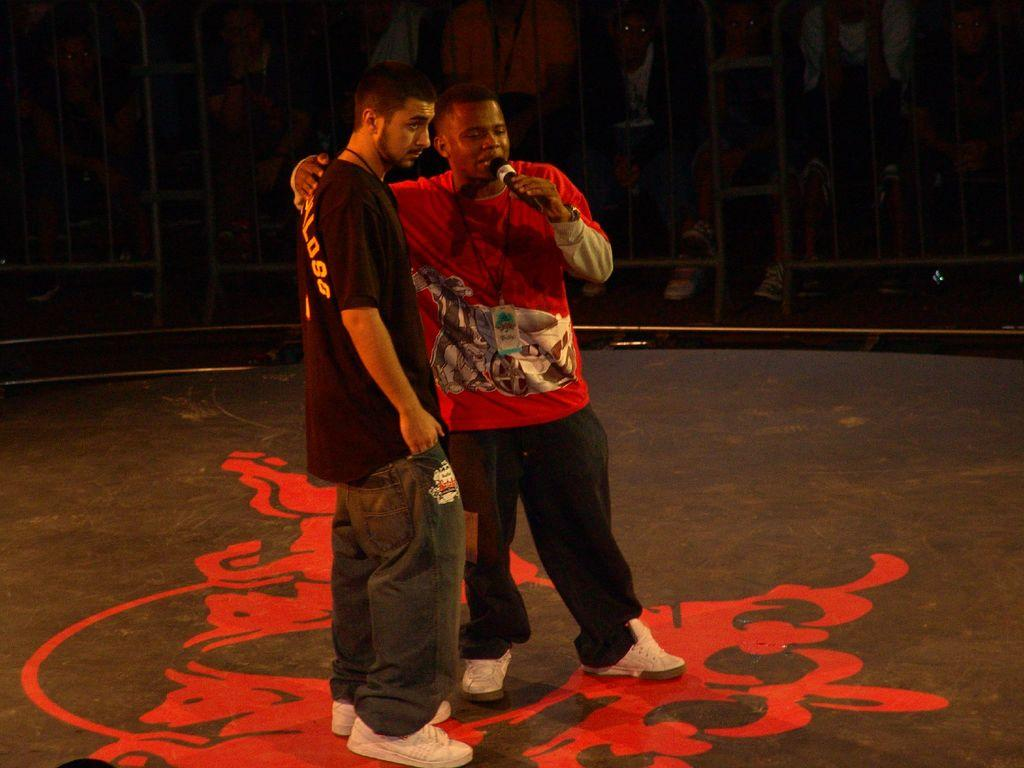How many people are in the image? There are two persons standing in the image. What is one of the persons holding? One of the persons is holding a microphone. What can be observed about the background of the image? The background of the image is dark. Can you see any fog in the image? There is no fog present in the image. What type of board is being used by the person holding the microphone? There is no board present in the image. 